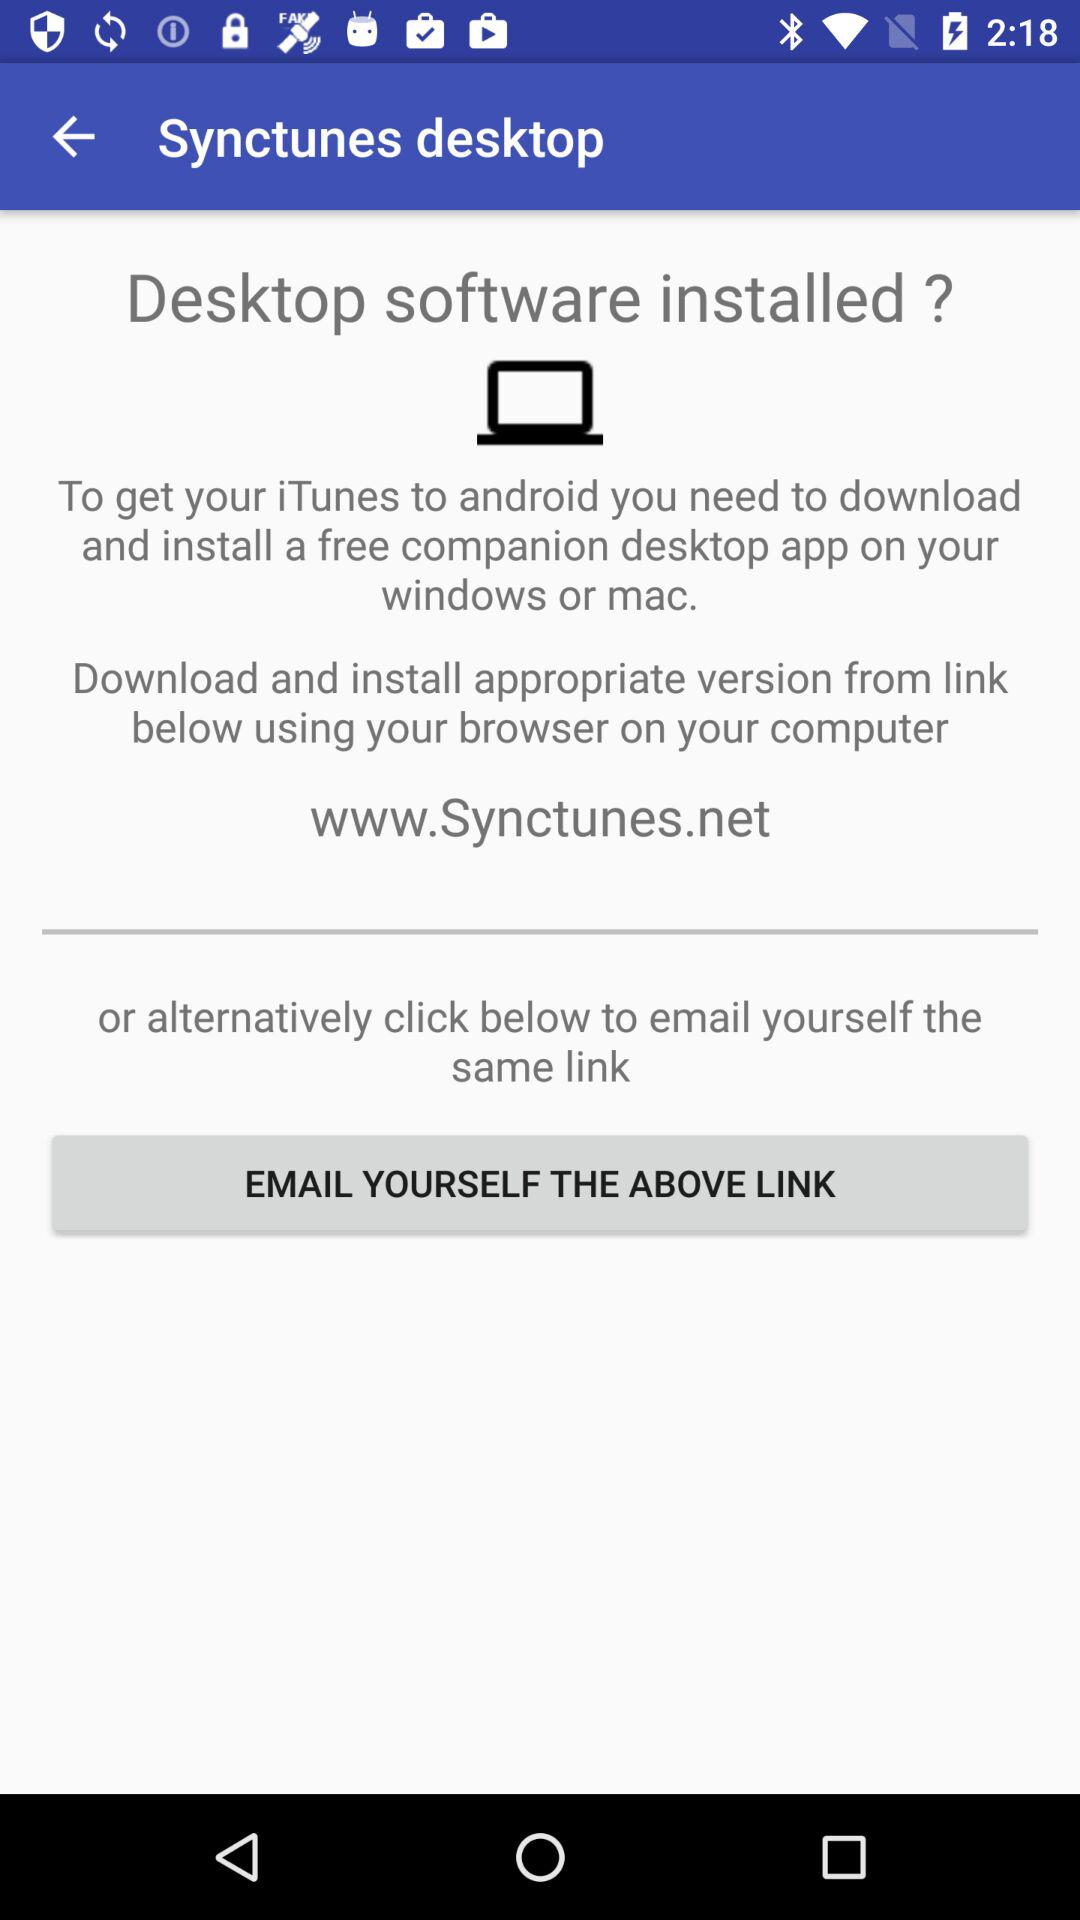What is the link to download and install the appropriate version? The link is "www.Synctunes.net". 